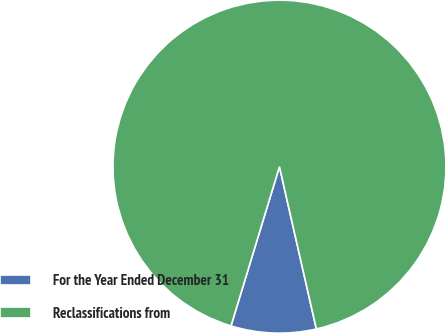Convert chart to OTSL. <chart><loc_0><loc_0><loc_500><loc_500><pie_chart><fcel>For the Year Ended December 31<fcel>Reclassifications from<nl><fcel>8.26%<fcel>91.74%<nl></chart> 